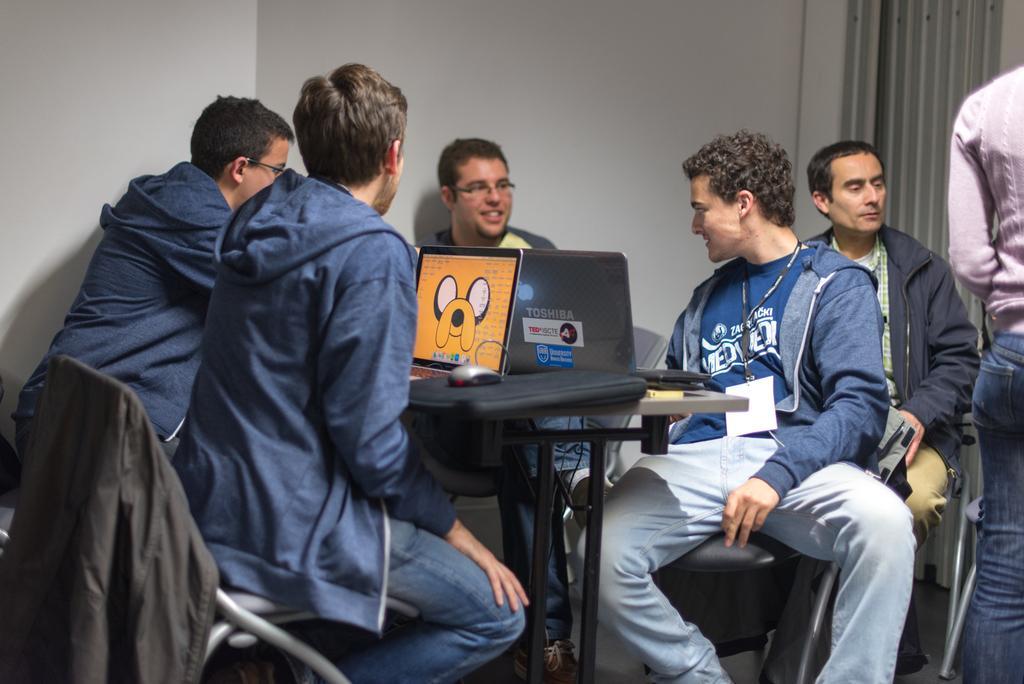Please provide a concise description of this image. This picture describes about group of people, few are sitting on the chairs, in front of them we can see few laptops, mouse and other things on the table. 